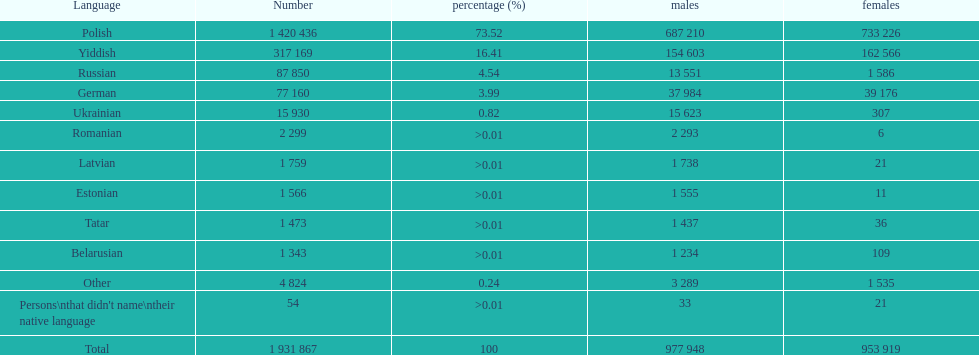Is german above or below russia in the number of people who speak that language? Below. 